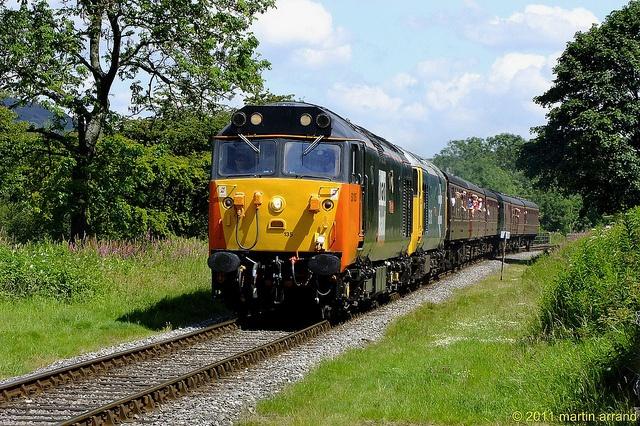Describe the objects in this image and their specific colors. I can see train in gray, black, orange, and olive tones, people in gray, navy, black, and darkblue tones, people in gray, blue, and navy tones, people in gray, lightgray, lightpink, and brown tones, and people in gray, darkgray, lightgray, and brown tones in this image. 